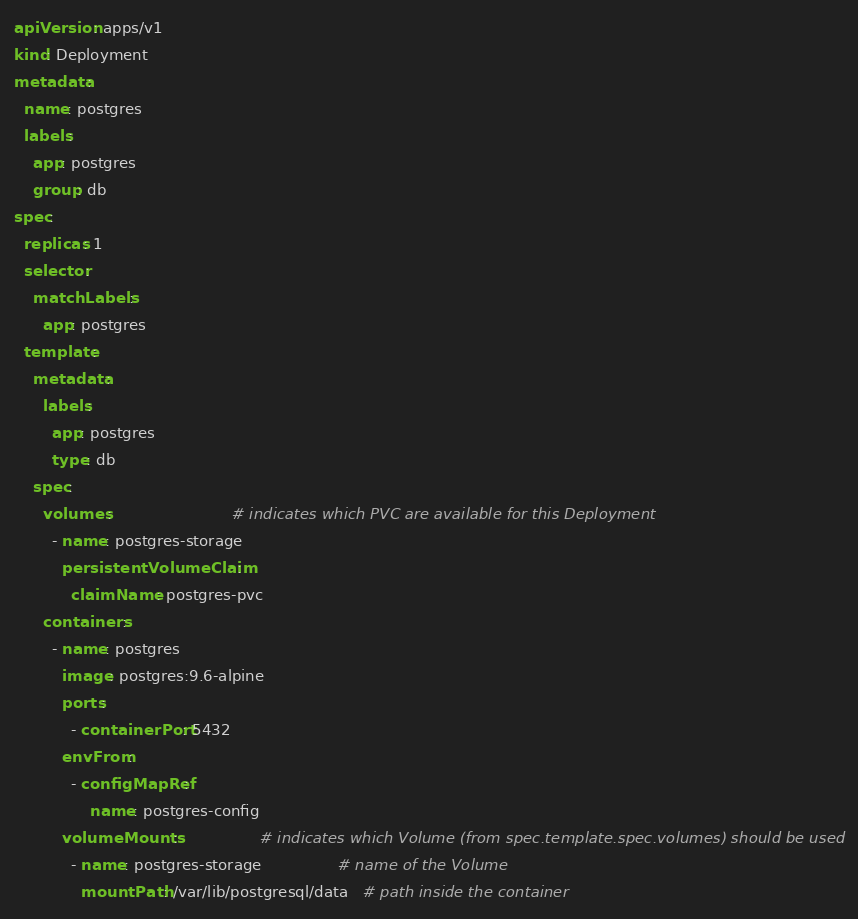<code> <loc_0><loc_0><loc_500><loc_500><_YAML_>
apiVersion: apps/v1
kind: Deployment
metadata:
  name: postgres
  labels:
    app: postgres
    group: db
spec:
  replicas: 1
  selector:
    matchLabels:
      app: postgres
  template:
    metadata:
      labels:
        app: postgres
        type: db
    spec:
      volumes:                         # indicates which PVC are available for this Deployment
        - name: postgres-storage
          persistentVolumeClaim:
            claimName: postgres-pvc
      containers:
        - name: postgres
          image: postgres:9.6-alpine
          ports:
            - containerPort: 5432
          envFrom:
            - configMapRef:
                name: postgres-config
          volumeMounts:                 # indicates which Volume (from spec.template.spec.volumes) should be used
            - name: postgres-storage                # name of the Volume
              mountPath: /var/lib/postgresql/data   # path inside the container</code> 